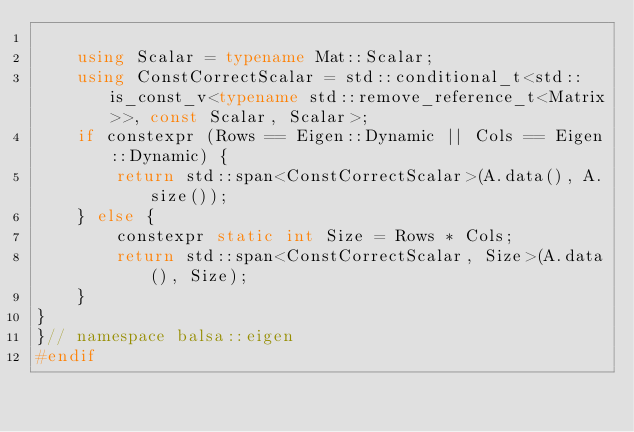<code> <loc_0><loc_0><loc_500><loc_500><_C++_>
    using Scalar = typename Mat::Scalar;
    using ConstCorrectScalar = std::conditional_t<std::is_const_v<typename std::remove_reference_t<Matrix>>, const Scalar, Scalar>;
    if constexpr (Rows == Eigen::Dynamic || Cols == Eigen::Dynamic) {
        return std::span<ConstCorrectScalar>(A.data(), A.size());
    } else {
        constexpr static int Size = Rows * Cols;
        return std::span<ConstCorrectScalar, Size>(A.data(), Size);
    }
}
}// namespace balsa::eigen
#endif
</code> 